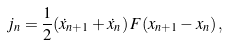<formula> <loc_0><loc_0><loc_500><loc_500>j _ { n } = \frac { 1 } { 2 } ( { \dot { x } } _ { n + 1 } + { \dot { x } } _ { n } ) \, F ( x _ { n + 1 } - x _ { n } ) \, ,</formula> 